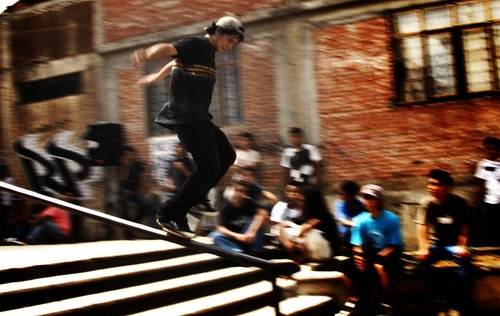Describe the objects in this image and their specific colors. I can see people in white, black, maroon, and gray tones, people in white, black, navy, maroon, and teal tones, people in white, black, maroon, brown, and orange tones, people in white, black, maroon, and tan tones, and people in white, black, maroon, brown, and tan tones in this image. 